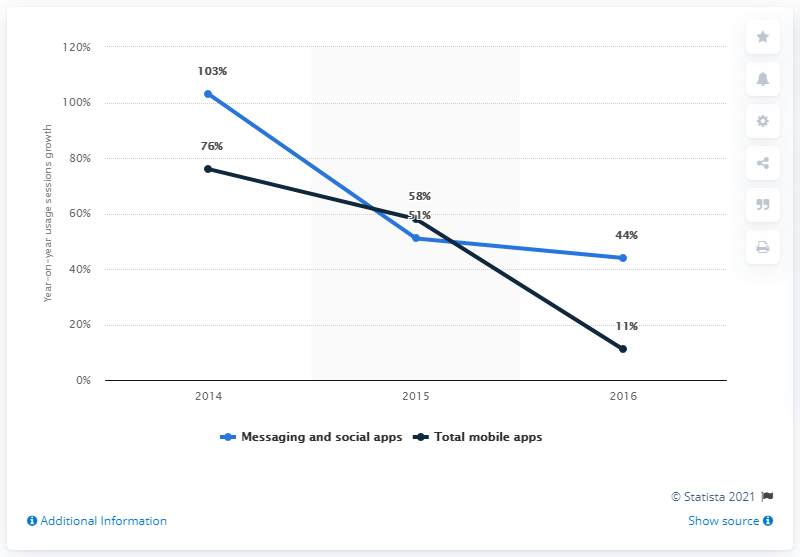Mention a couple of crucial points in this snapshot. Overall app usage sessions increased by a significant percentage from 2015 to 2016. 